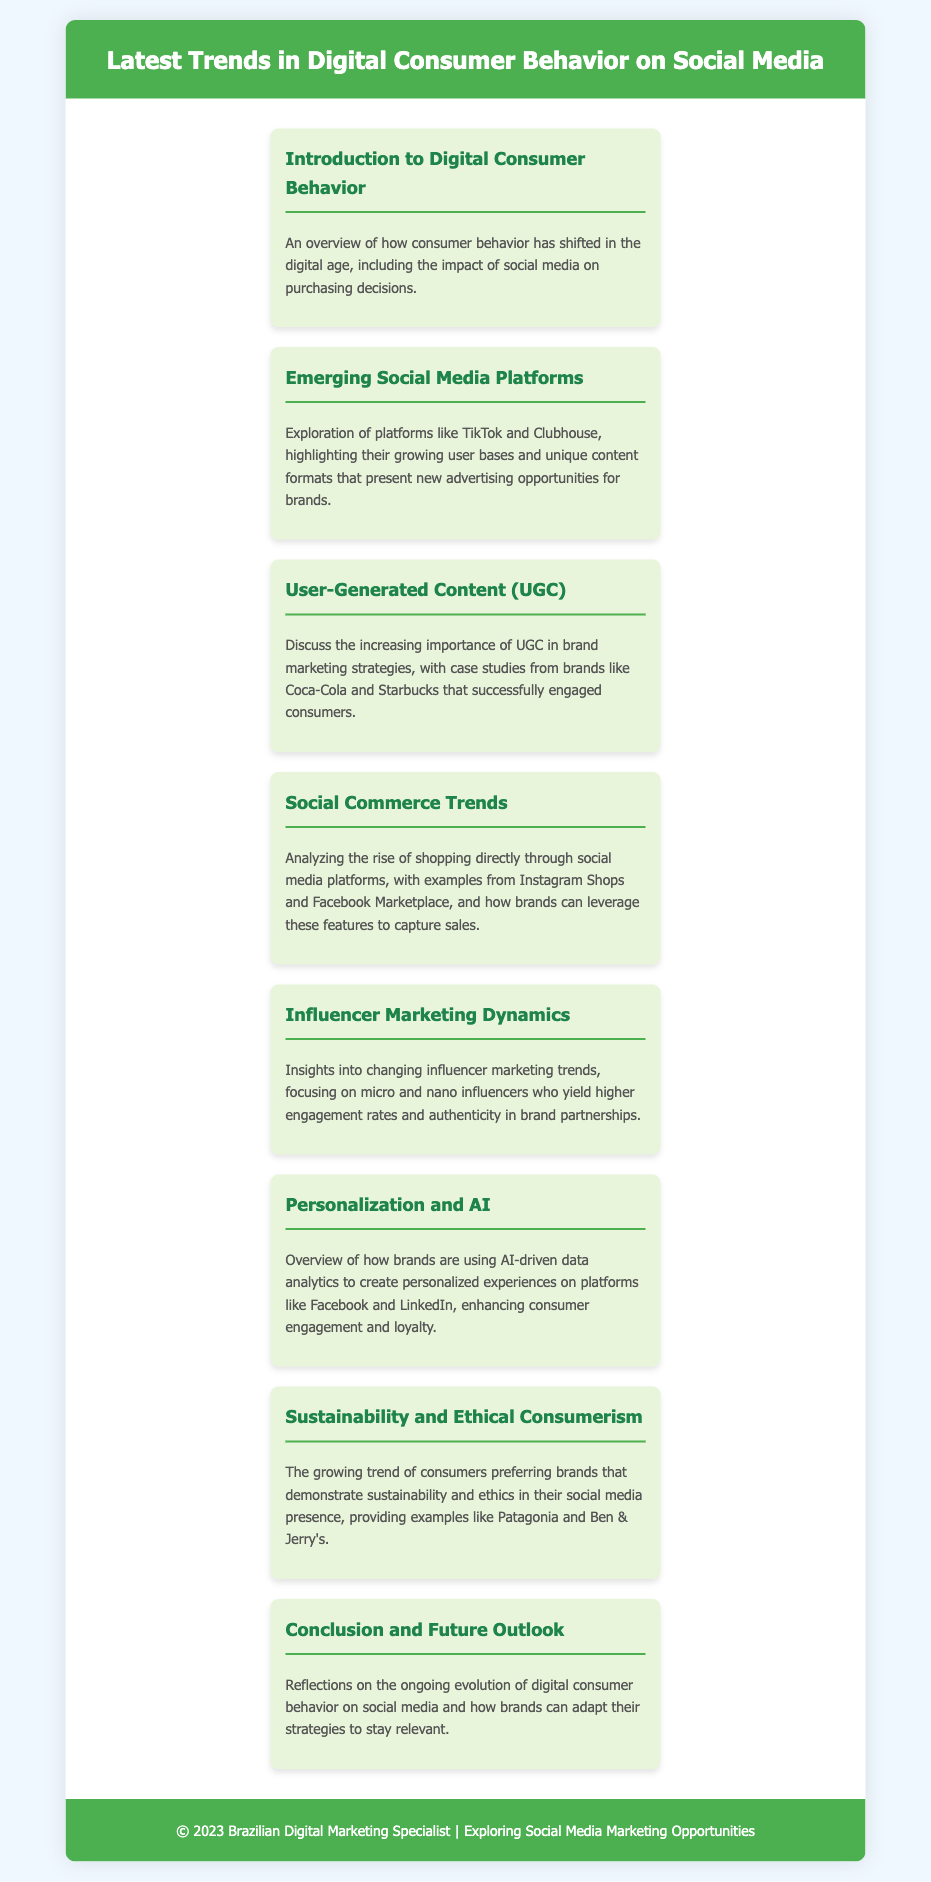What is the title of the document? The title of the document is displayed in the header, highlighting the focus on trends.
Answer: Latest Trends in Digital Consumer Behavior on Social Media How many menu items are presented in the document? The document contains multiple sections, each represented as a menu item, which totals eight.
Answer: 8 What is one new social media platform explored in the document? The document specifically mentions TikTok as an emerging platform gaining user attention.
Answer: TikTok Which marketing strategy emphasizes consumer-generated content? The menu item discusses this important aspect of marketing strategies that brands are adopting more frequently today.
Answer: User-Generated Content (UGC) What trend focuses on shopping directly through social media? This trend highlights the integration of e-commerce functionalities within social networks.
Answer: Social Commerce Trends Who are the influencers mentioned that yield higher engagement rates? The document specifies a type of influencer that is becoming more popular due to their authenticity.
Answer: Micro and nano influencers What major theme regarding consumer behavior is discussed in the conclusion? The document reflects on this theme to highlight necessary adaptations in marketing strategies.
Answer: Ongoing evolution Which brand is associated with demonstrating sustainability in its social media presence? The document cites a well-known brand that emphasizes ethical consumerism and responsible marketing.
Answer: Patagonia 